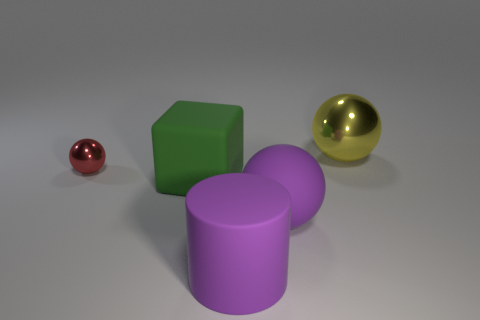What number of other objects are there of the same shape as the green thing?
Your answer should be compact. 0. What shape is the large object that is on the right side of the large purple cylinder and in front of the large yellow sphere?
Provide a short and direct response. Sphere. There is a shiny object right of the purple rubber object that is left of the large rubber object that is on the right side of the cylinder; what color is it?
Provide a succinct answer. Yellow. Are there more large cylinders that are in front of the red thing than big green matte blocks on the right side of the big metal thing?
Give a very brief answer. Yes. How many other objects are there of the same size as the purple rubber cylinder?
Give a very brief answer. 3. What is the large object behind the shiny thing that is in front of the yellow metallic sphere made of?
Give a very brief answer. Metal. Are there any large rubber spheres to the left of the small thing?
Your response must be concise. No. Is the number of big rubber things behind the big cylinder greater than the number of red rubber blocks?
Provide a short and direct response. Yes. Are there any large rubber objects that have the same color as the big matte ball?
Offer a terse response. Yes. There is a metal ball that is the same size as the rubber cylinder; what color is it?
Your response must be concise. Yellow. 